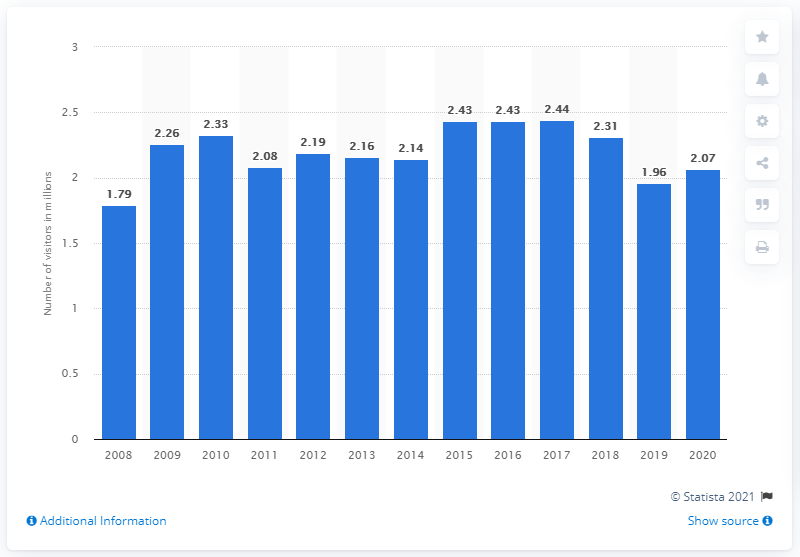Give some essential details in this illustration. In 2020, the Mount Rushmore National Memorial was visited by 2,070 people. 